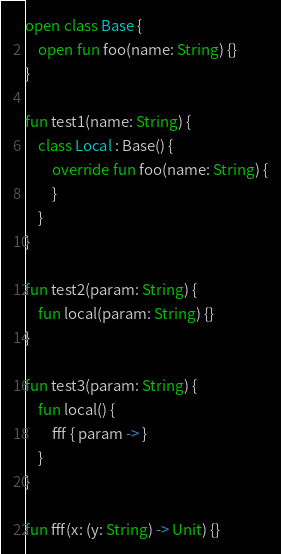<code> <loc_0><loc_0><loc_500><loc_500><_Kotlin_>open class Base {
    open fun foo(name: String) {}
}

fun test1(name: String) {
    class Local : Base() {
        override fun foo(name: String) {
        }
    }
}

fun test2(param: String) {
    fun local(param: String) {}
}

fun test3(param: String) {
    fun local() {
        fff { param -> }
    }
}

fun fff(x: (y: String) -> Unit) {}</code> 